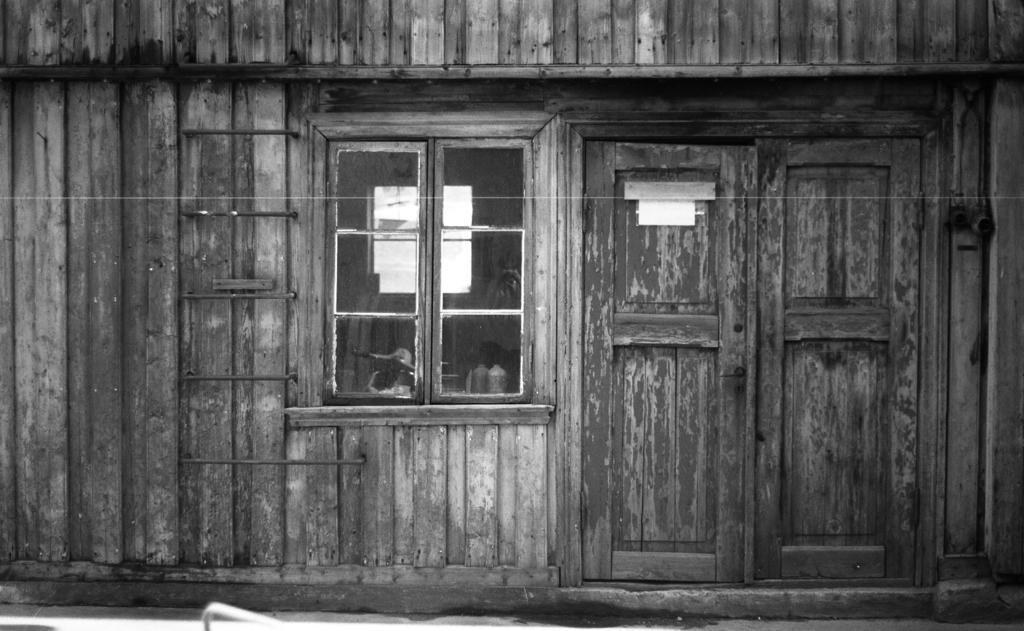Please provide a concise description of this image. This is a black and white picture. It looks like a wooden house. In this picture we can see a ladder, reflection on the window glass. We can see a door and few objects. 